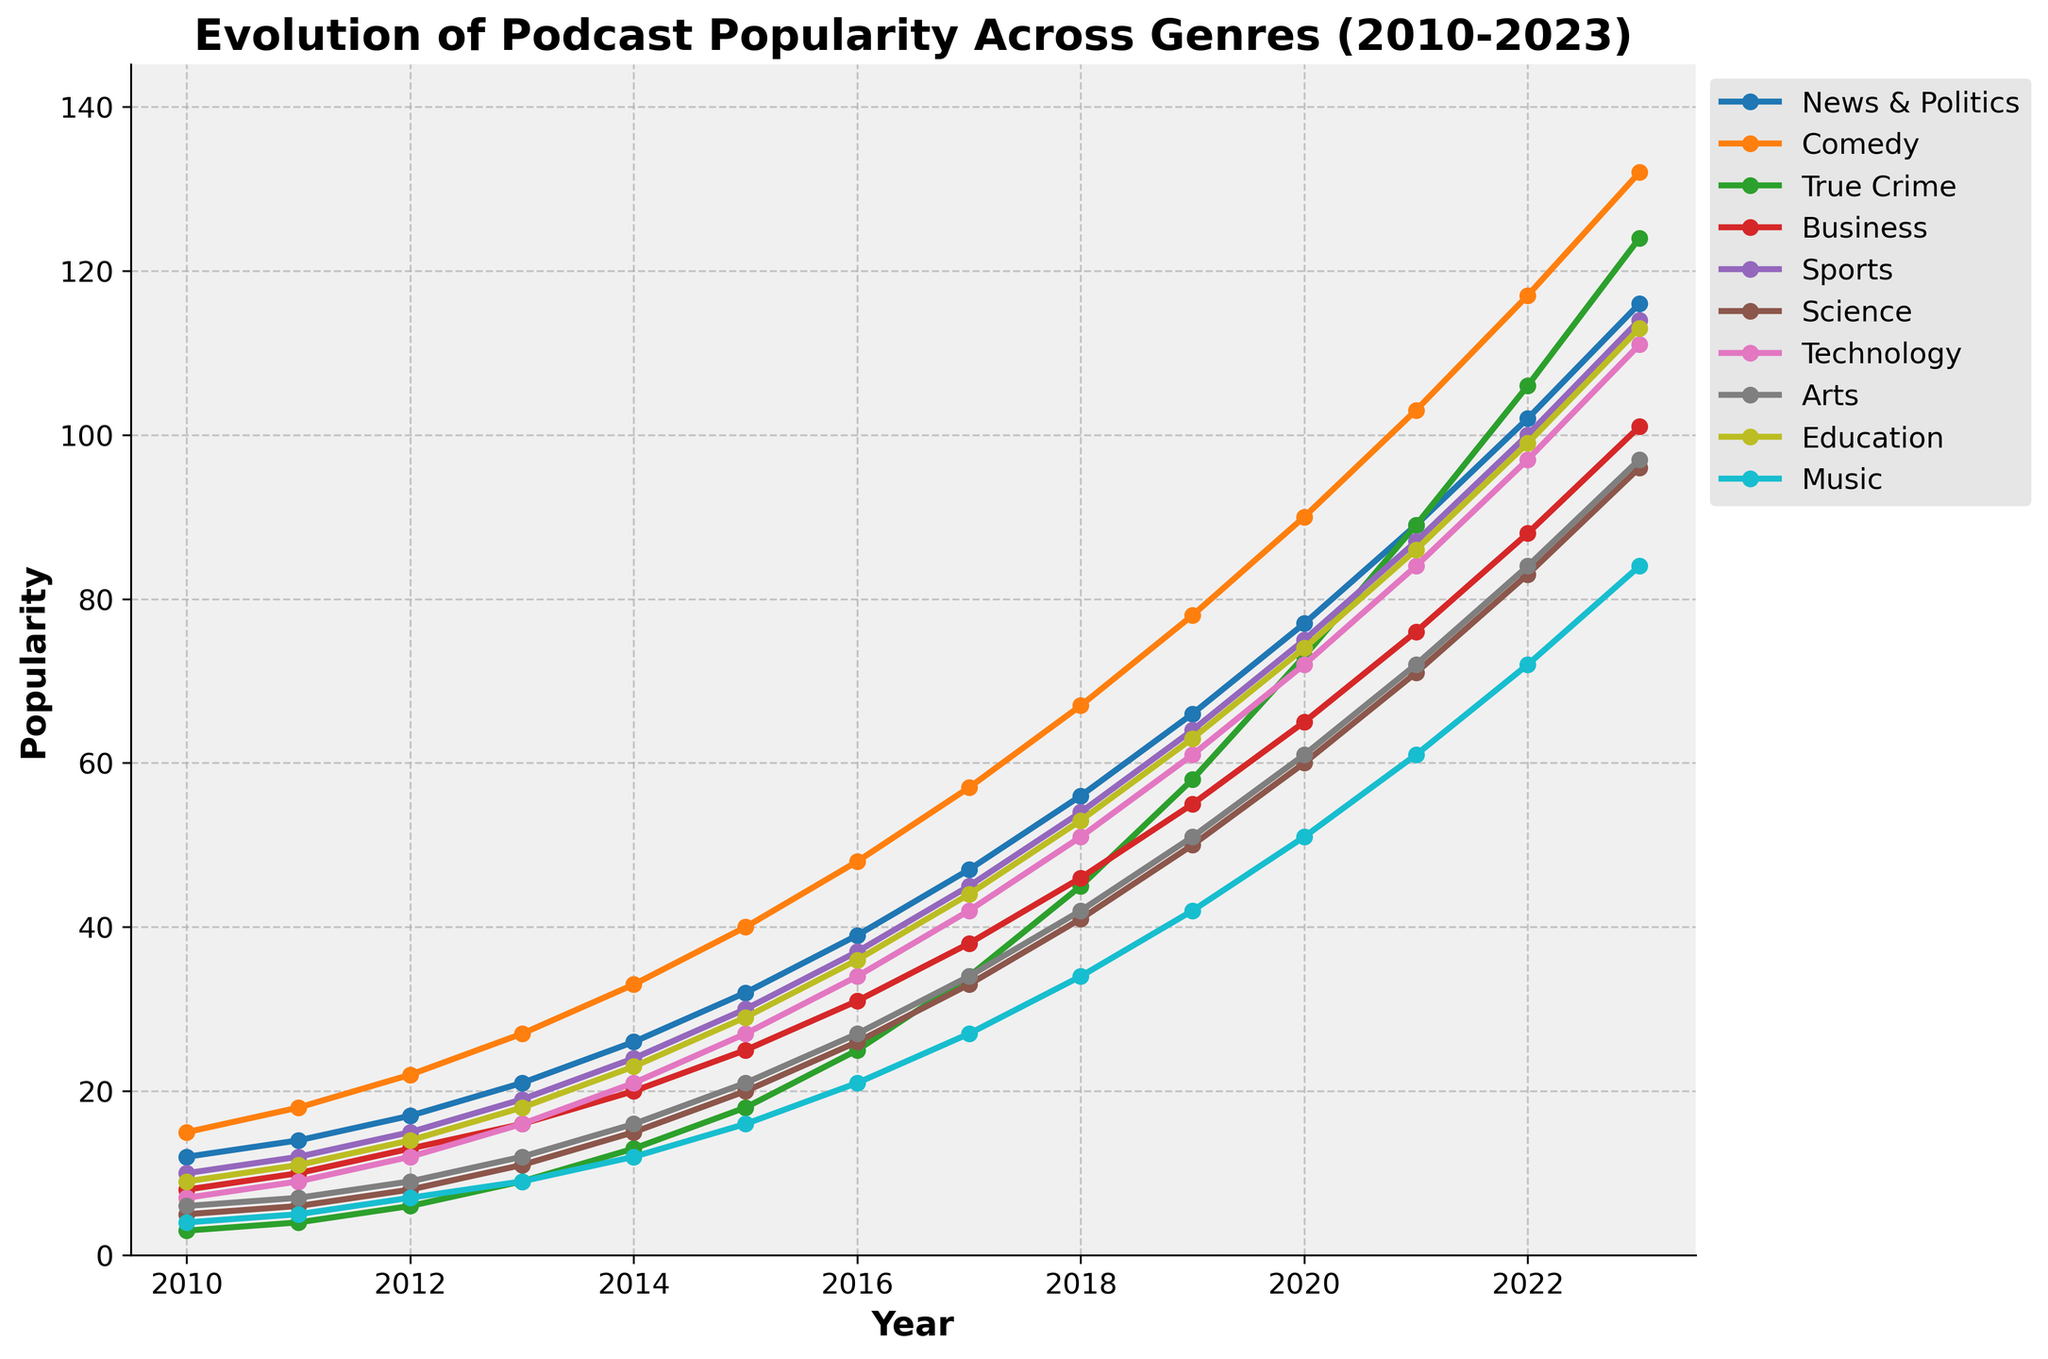What's the most popular podcast genre in 2023? Identify and compare the values for 2023 across all genres. The highest value represents the most popular genre. In 2023, "Comedy" has the highest popularity value.
Answer: Comedy Which genre saw the largest increase in popularity from 2010 to 2023? Calculate the difference in popularity values between 2023 and 2010 for each genre. Identify the genre with the highest increase. Comedy: 132 - 15 = 117, True Crime: 124 - 3 = 121, etc. Comedy increased the most by 117 points.
Answer: Comedy By how many points did the popularity of True Crime increase from 2010 to 2022? Subtract the 2010 value for True Crime from the 2022 value. 2022 value is 106, and 2010 value is 3. So, 106 - 3 = 103 points increase.
Answer: 103 Between 2018 and 2019, which genre had the highest growth rate? Calculate the growth rate for each genre from 2018 to 2019: (value in 2019 - value in 2018) / value in 2018 * 100%. Compare the rates to find the highest. True Crime: (58 - 45) / 45 * 100% = 28.89%, which is the highest among all genres.
Answer: True Crime What is the average popularity of the "Science" genre from 2010 to 2023? Sum up the popularity values for Science from 2010 to 2023 and divide by the number of years (14). ((5+6+8+11+15+20+26+33+41+50+60+71+83+96)/14 = 36.36).
Answer: 36.36 Which year did the "News & Politics" genre surpass the "Sports" genre in popularity? Compare the values of News & Politics and Sports for each year from 2010 onwards until News & Politics value is greater. In 2015, News & Politics (32) surpassed Sports (30).
Answer: 2015 What is the trend of popularity for the "Business" genre from 2010 to 2023? Identify if the popularity values for Business increase, decrease, or remain constant over the years. Business shows a consistent rise in popularity every year from 2010 (8) to 2023 (101).
Answer: Increasing How does the popularity of "Music" in 2022 compare with "Education" in 2016? Find the popularity values for Music in 2022 and Education in 2016 and compare them. Music in 2022 has a value of 72, and Education in 2016 has a value of 36, so Music in 2022 is twice as popular as Education in 2016.
Answer: 2 times What is the visual indication for the most popular genres in each year? Look for the longest line segment or highest point at each year marker. In 2023, Comedy is the highest; in 2020, Comedy; in 2015, Comedy; and so on. Each year, Comedy has the highest values and the most prominent line.
Answer: Line pointing at Comedy Summarize the trend for the "Education" genre from 2010 to 2023. Observe the line for Education over the years to determine whether it rises, falls, or stays constant. The Education genre shows a consistent upward trend from 9 in 2010 to 113 in 2023.
Answer: Upward trend 